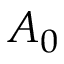<formula> <loc_0><loc_0><loc_500><loc_500>A _ { 0 }</formula> 